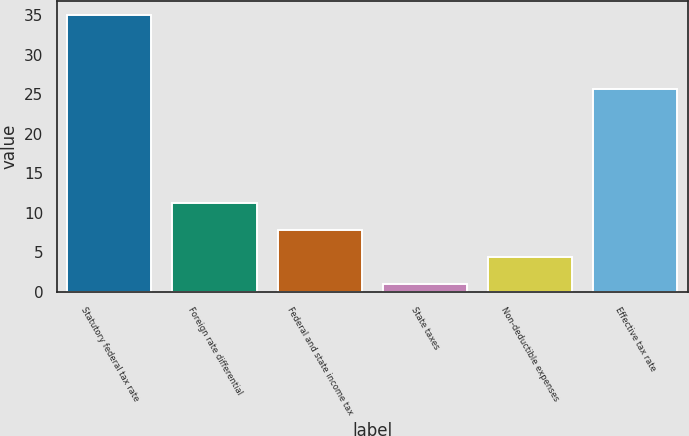Convert chart. <chart><loc_0><loc_0><loc_500><loc_500><bar_chart><fcel>Statutory federal tax rate<fcel>Foreign rate differential<fcel>Federal and state income tax<fcel>State taxes<fcel>Non-deductible expenses<fcel>Effective tax rate<nl><fcel>35<fcel>11.2<fcel>7.8<fcel>1<fcel>4.4<fcel>25.7<nl></chart> 